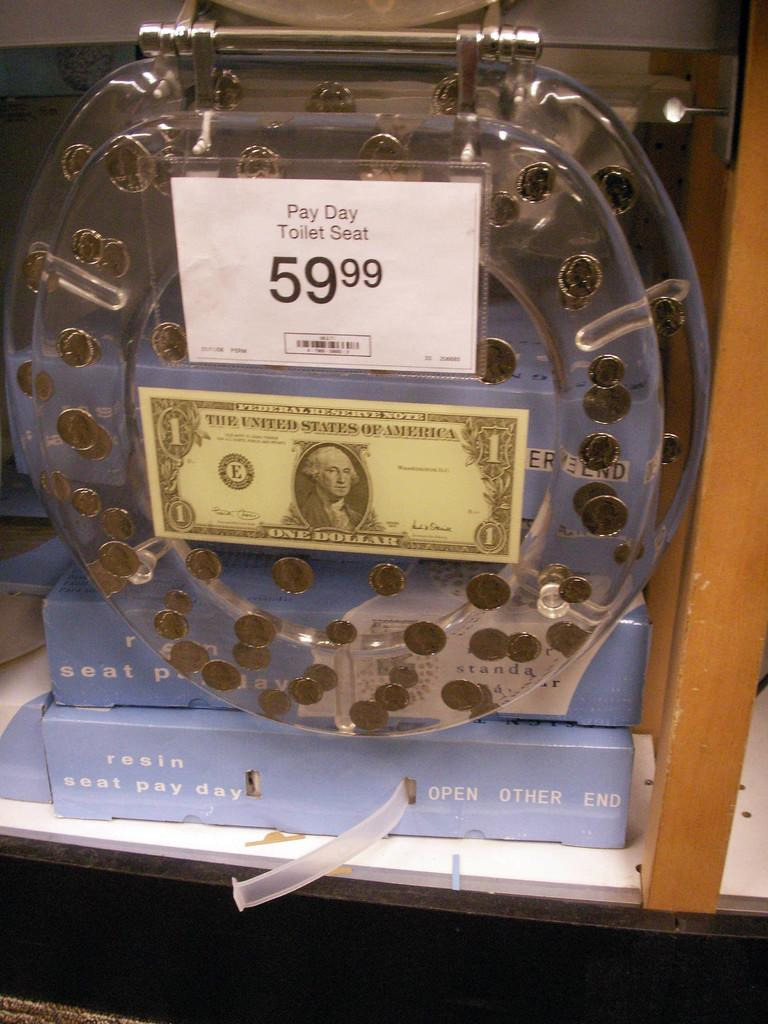Provide a one-sentence caption for the provided image. "Pay Day Toilet Seat" a clear toilet seat with coins embedded inside on sale for 59.99. 